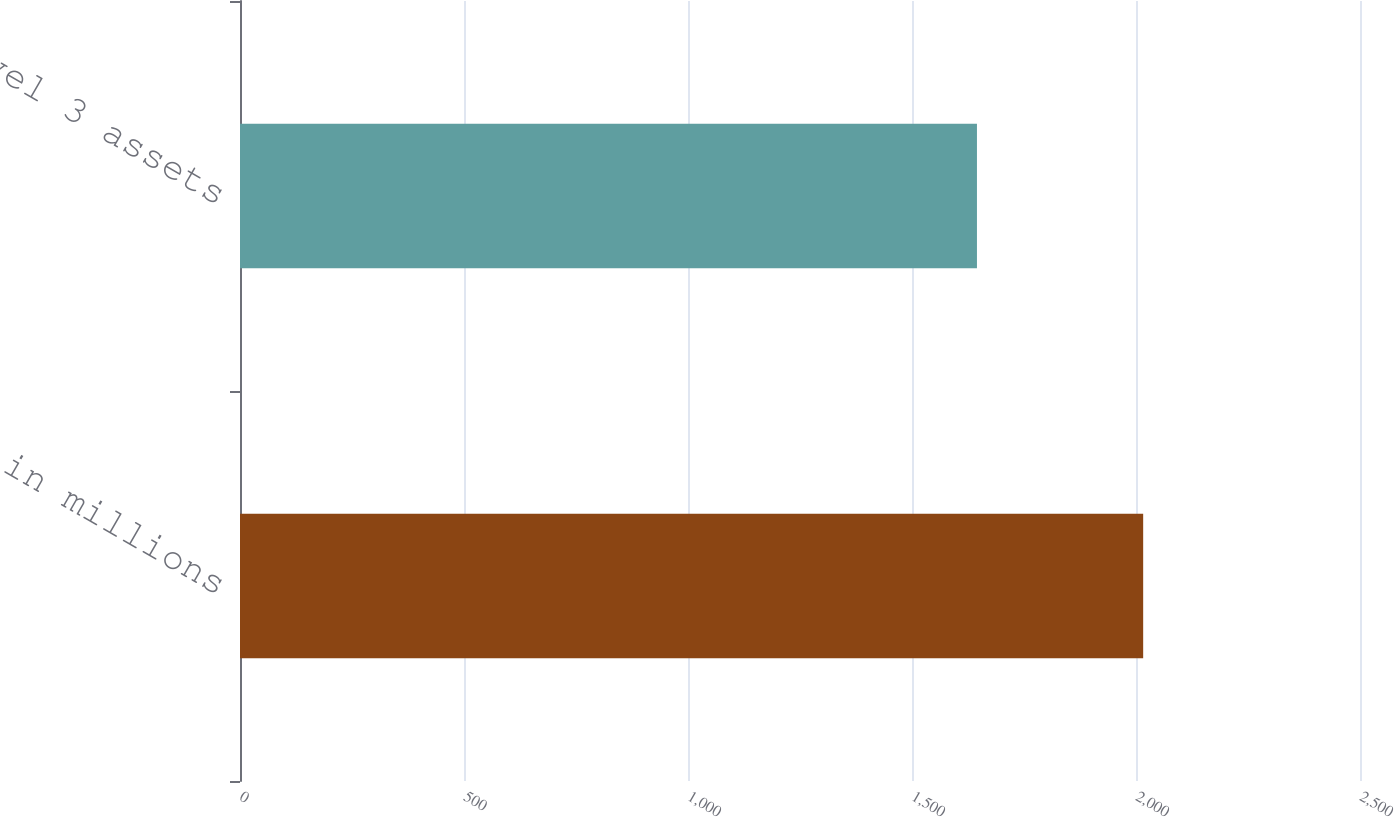Convert chart to OTSL. <chart><loc_0><loc_0><loc_500><loc_500><bar_chart><fcel>in millions<fcel>Level 3 assets<nl><fcel>2016<fcel>1645<nl></chart> 